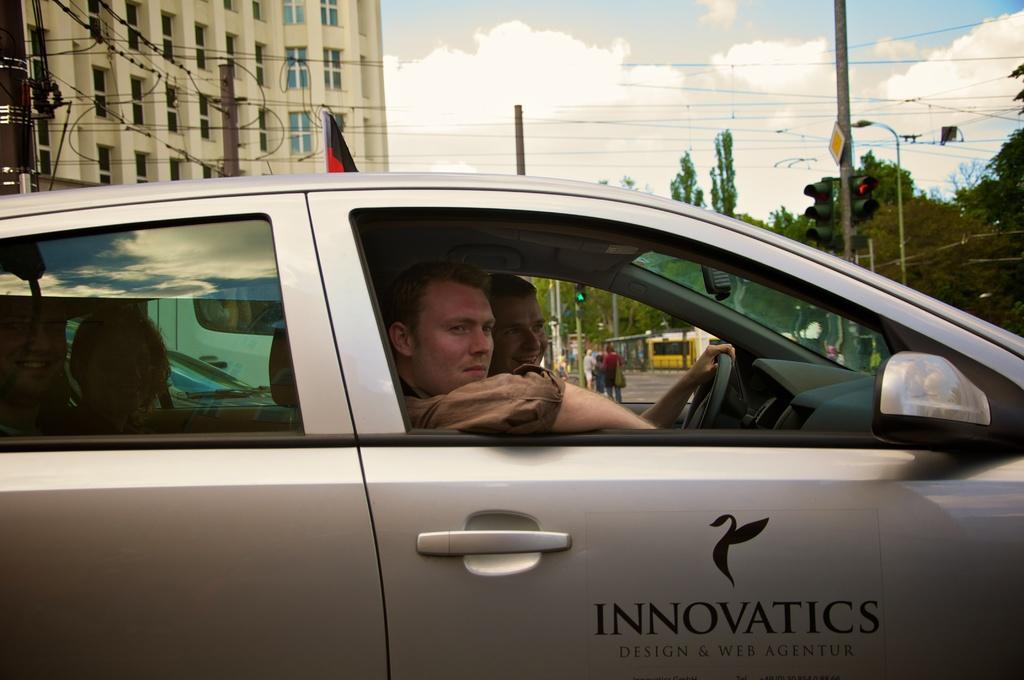Can you describe this image briefly? Picture is taken on the road where two persons are sitting inside the car and beside them there are trees and signal lights and buildings and flag and at the middle of the picture there are people walking on the road and there is sky. 